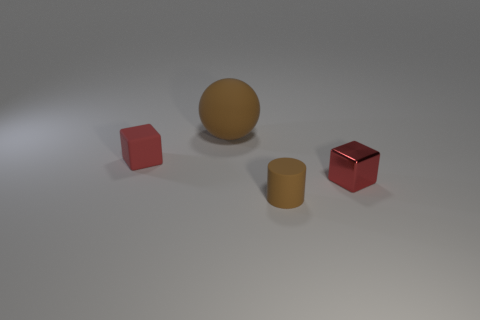If this scene were part of a video game, what kind of environment could it be representing? This scene could represent a puzzle or testing environment within a video game, possibly a minimalist room where a player is tasked with manipulating objects. The clean and simple aesthetic could suggest a focus on logic and problem-solving. 